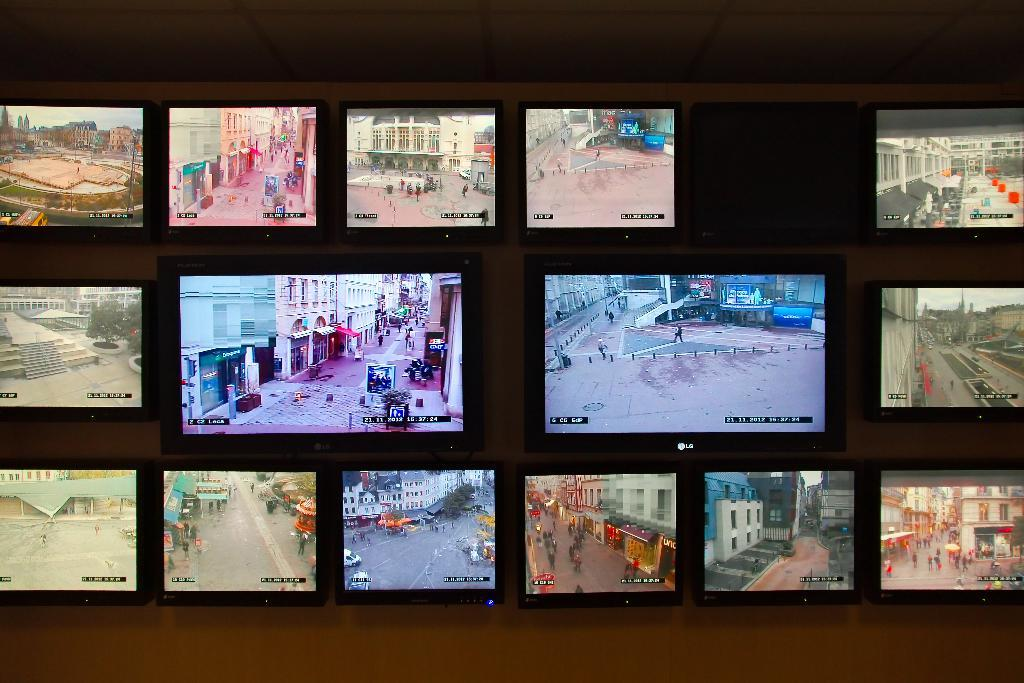What is mounted on the wall in the image? There are televisions on the wall in the image. How many televisions can be seen on the wall? The image only shows televisions on the wall, but the exact number is not specified. What theory is being discussed by the branch in the image? There is no branch present in the image, and therefore no theory can be discussed by it. 